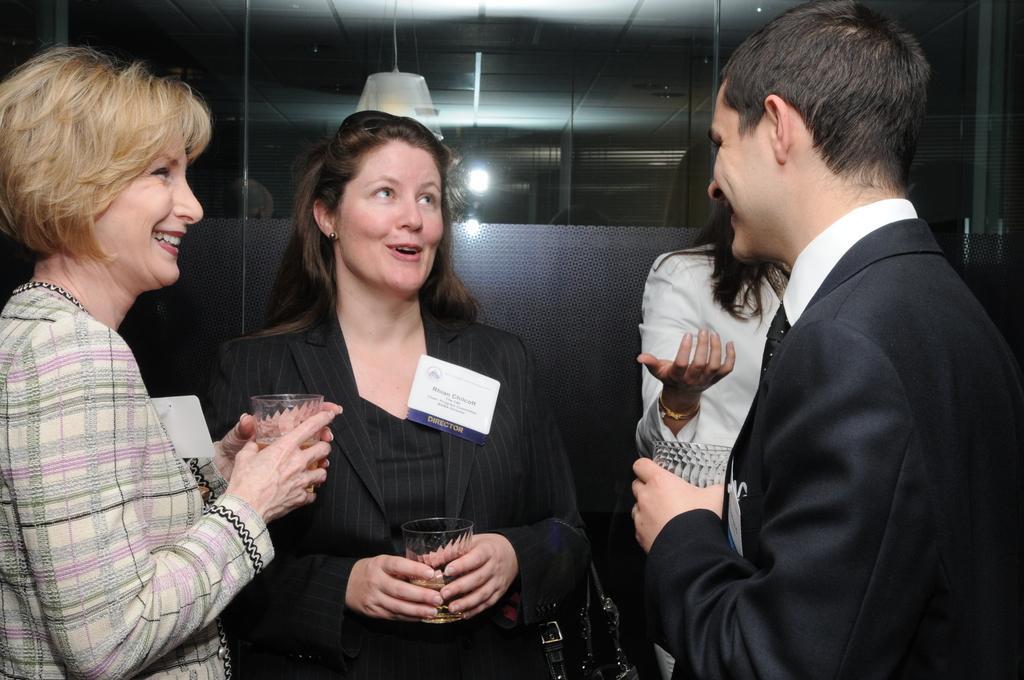In one or two sentences, can you explain what this image depicts? In this image I can see the group of people with different color dresses. I can see three people are holding the glasses. In the background I can see the lights in the glass. 